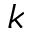Convert formula to latex. <formula><loc_0><loc_0><loc_500><loc_500>k</formula> 